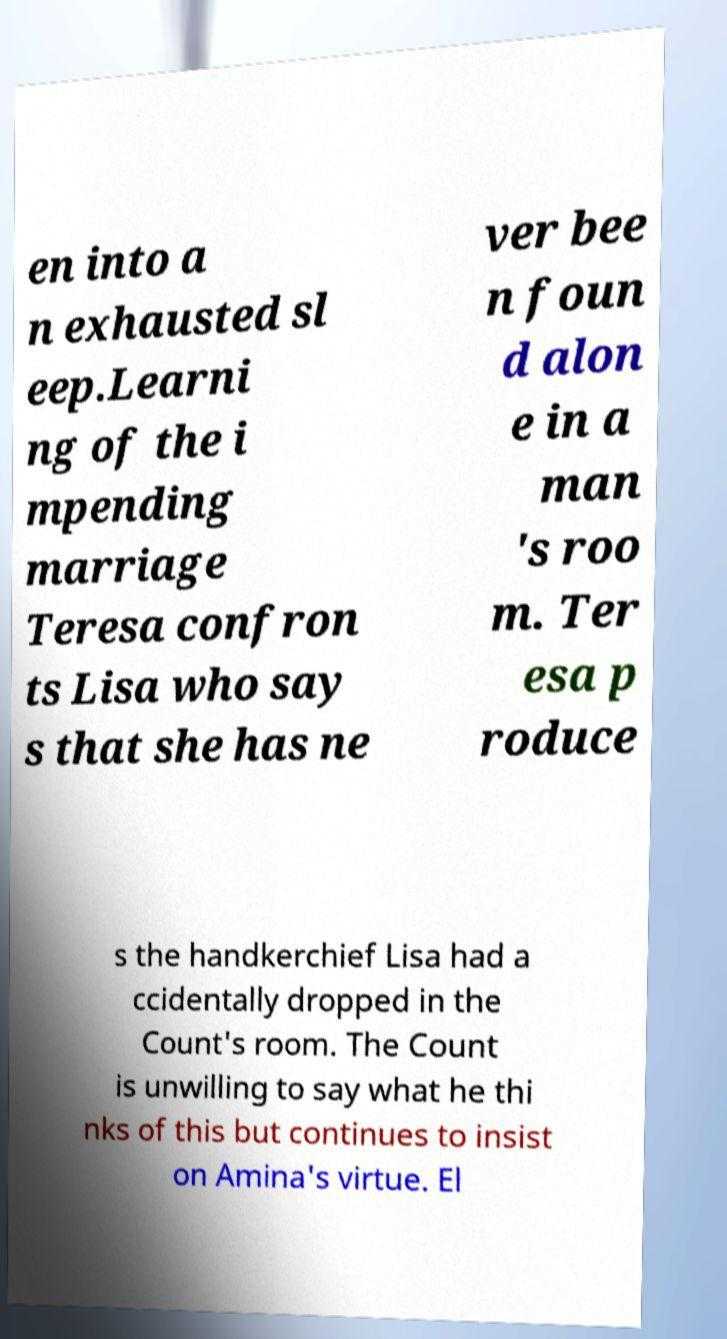There's text embedded in this image that I need extracted. Can you transcribe it verbatim? en into a n exhausted sl eep.Learni ng of the i mpending marriage Teresa confron ts Lisa who say s that she has ne ver bee n foun d alon e in a man 's roo m. Ter esa p roduce s the handkerchief Lisa had a ccidentally dropped in the Count's room. The Count is unwilling to say what he thi nks of this but continues to insist on Amina's virtue. El 